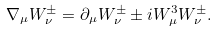Convert formula to latex. <formula><loc_0><loc_0><loc_500><loc_500>\nabla _ { \mu } W _ { \nu } ^ { \pm } = \partial _ { \mu } W _ { \nu } ^ { \pm } \pm i W _ { \mu } ^ { 3 } W _ { \nu } ^ { \pm } .</formula> 